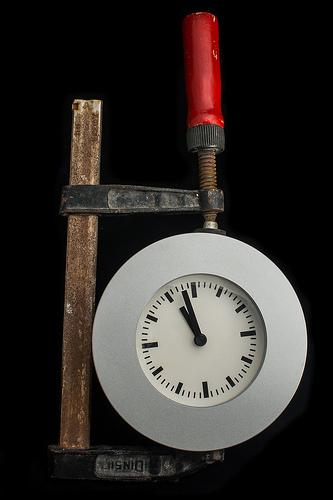Question: what color is the handle of the clamp?
Choices:
A. Orange.
B. Brown.
C. Red.
D. Yellow.
Answer with the letter. Answer: C Question: how is this clock held up?
Choices:
A. With a clamp.
B. Ropes.
C. Bolts.
D. Clamps.
Answer with the letter. Answer: A Question: when was this photo taken?
Choices:
A. 10:58.
B. 11:20.
C. 9:12.
D. 3:34.
Answer with the letter. Answer: A Question: what color are the hands of the clock?
Choices:
A. White.
B. Silver.
C. Grey.
D. Black.
Answer with the letter. Answer: D Question: what kind of simple machine is the red handle on?
Choices:
A. A screw.
B. Pulley.
C. Lever.
D. Switch.
Answer with the letter. Answer: A 